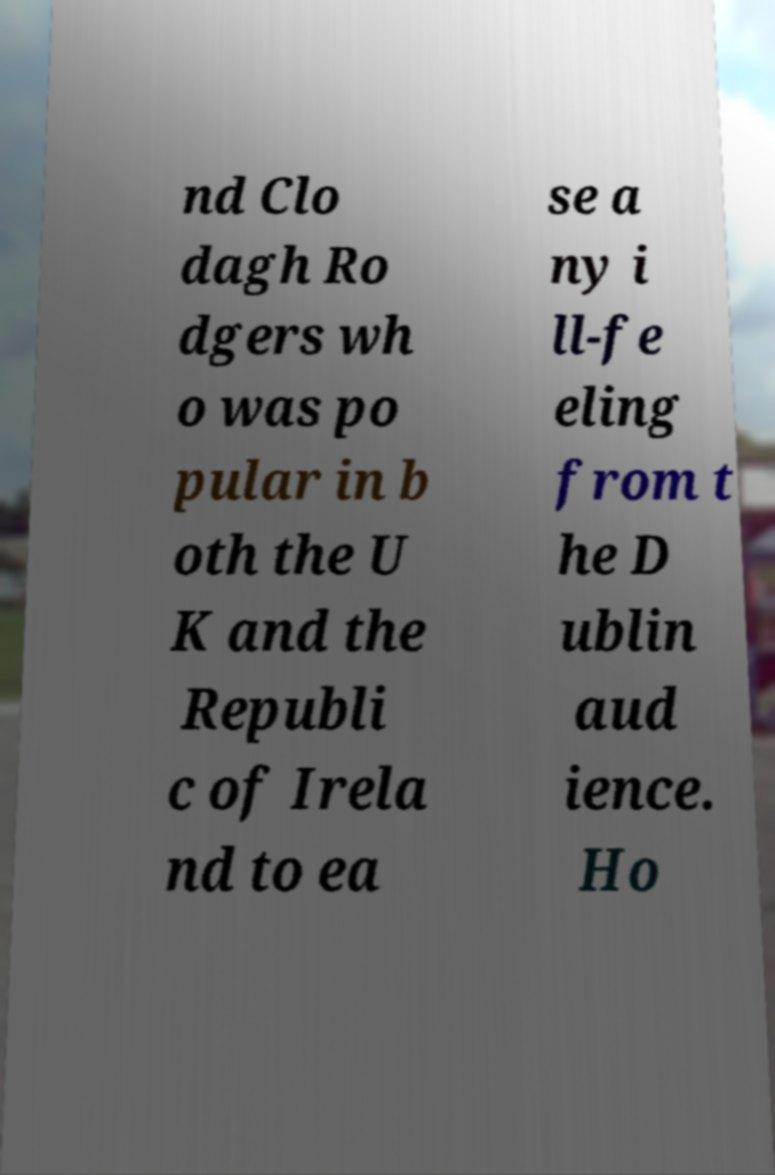Can you read and provide the text displayed in the image?This photo seems to have some interesting text. Can you extract and type it out for me? nd Clo dagh Ro dgers wh o was po pular in b oth the U K and the Republi c of Irela nd to ea se a ny i ll-fe eling from t he D ublin aud ience. Ho 